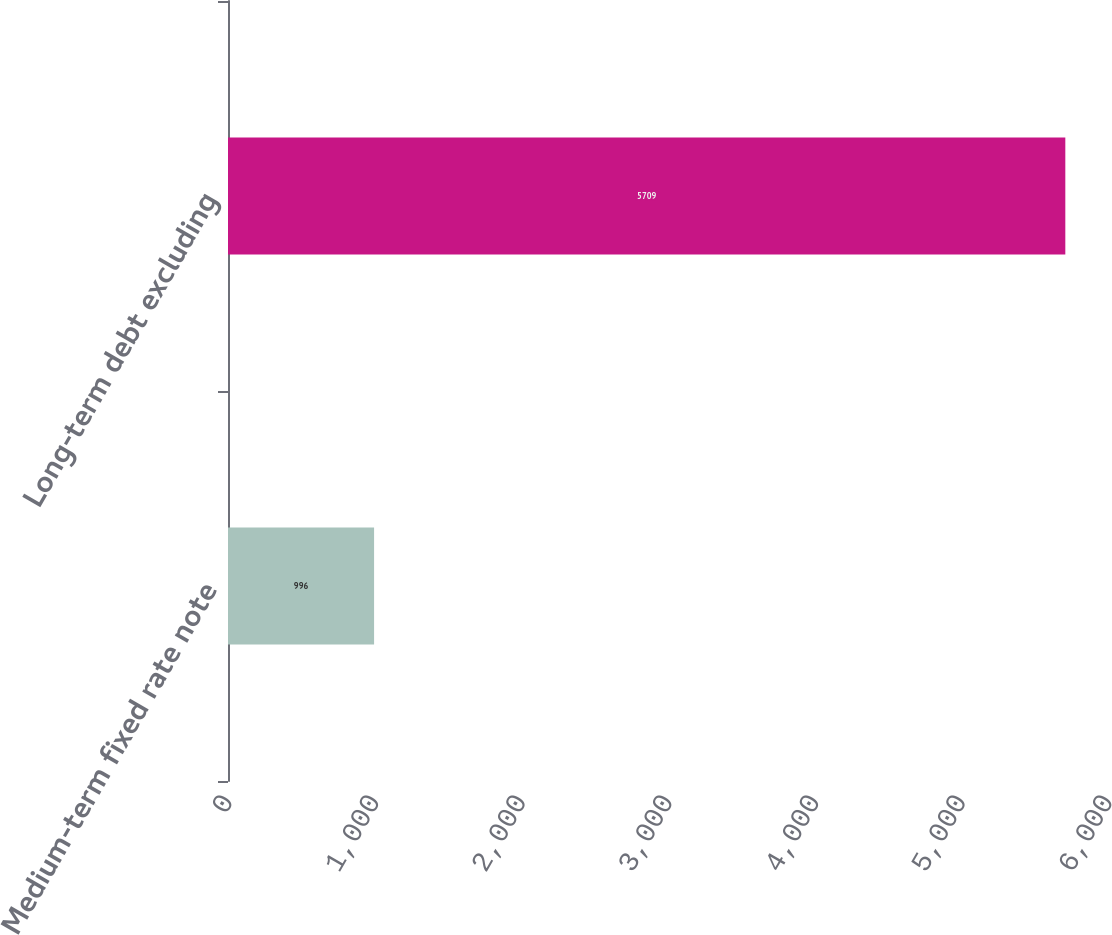Convert chart. <chart><loc_0><loc_0><loc_500><loc_500><bar_chart><fcel>Medium-term fixed rate note<fcel>Long-term debt excluding<nl><fcel>996<fcel>5709<nl></chart> 